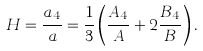Convert formula to latex. <formula><loc_0><loc_0><loc_500><loc_500>H = \frac { a _ { 4 } } { a } = \frac { 1 } { 3 } \left ( \frac { A _ { 4 } } { A } + 2 \frac { B _ { 4 } } { B } \right ) .</formula> 